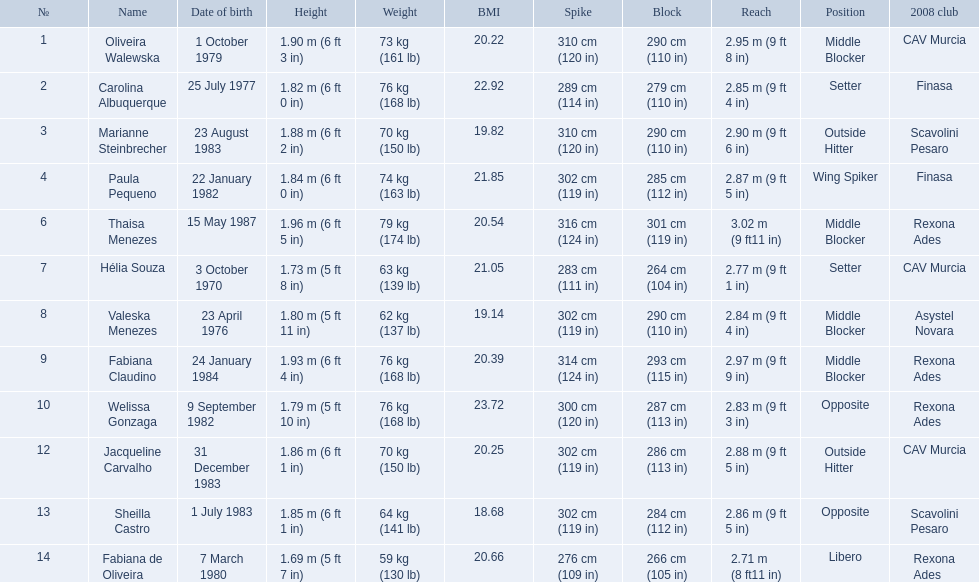What are the names of all the contestants? Oliveira Walewska, Carolina Albuquerque, Marianne Steinbrecher, Paula Pequeno, Thaisa Menezes, Hélia Souza, Valeska Menezes, Fabiana Claudino, Welissa Gonzaga, Jacqueline Carvalho, Sheilla Castro, Fabiana de Oliveira. What are the weight ranges of the contestants? 73 kg (161 lb), 76 kg (168 lb), 70 kg (150 lb), 74 kg (163 lb), 79 kg (174 lb), 63 kg (139 lb), 62 kg (137 lb), 76 kg (168 lb), 76 kg (168 lb), 70 kg (150 lb), 64 kg (141 lb), 59 kg (130 lb). Which player is heaviest. sheilla castro, fabiana de oliveira, or helia souza? Sheilla Castro. 